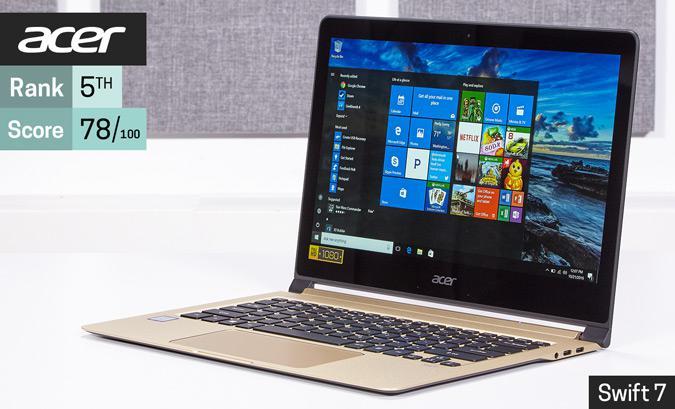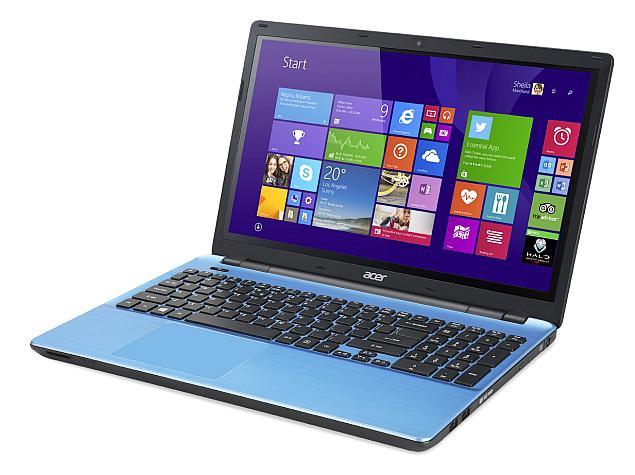The first image is the image on the left, the second image is the image on the right. Assess this claim about the two images: "The right image features a black laptop computer with a green and yellow background visible on its screen". Correct or not? Answer yes or no. No. The first image is the image on the left, the second image is the image on the right. Assess this claim about the two images: "All laptops are displayed on white backgrounds, and the laptop on the right shows yellow and green sections divided diagonally on the screen.". Correct or not? Answer yes or no. No. 